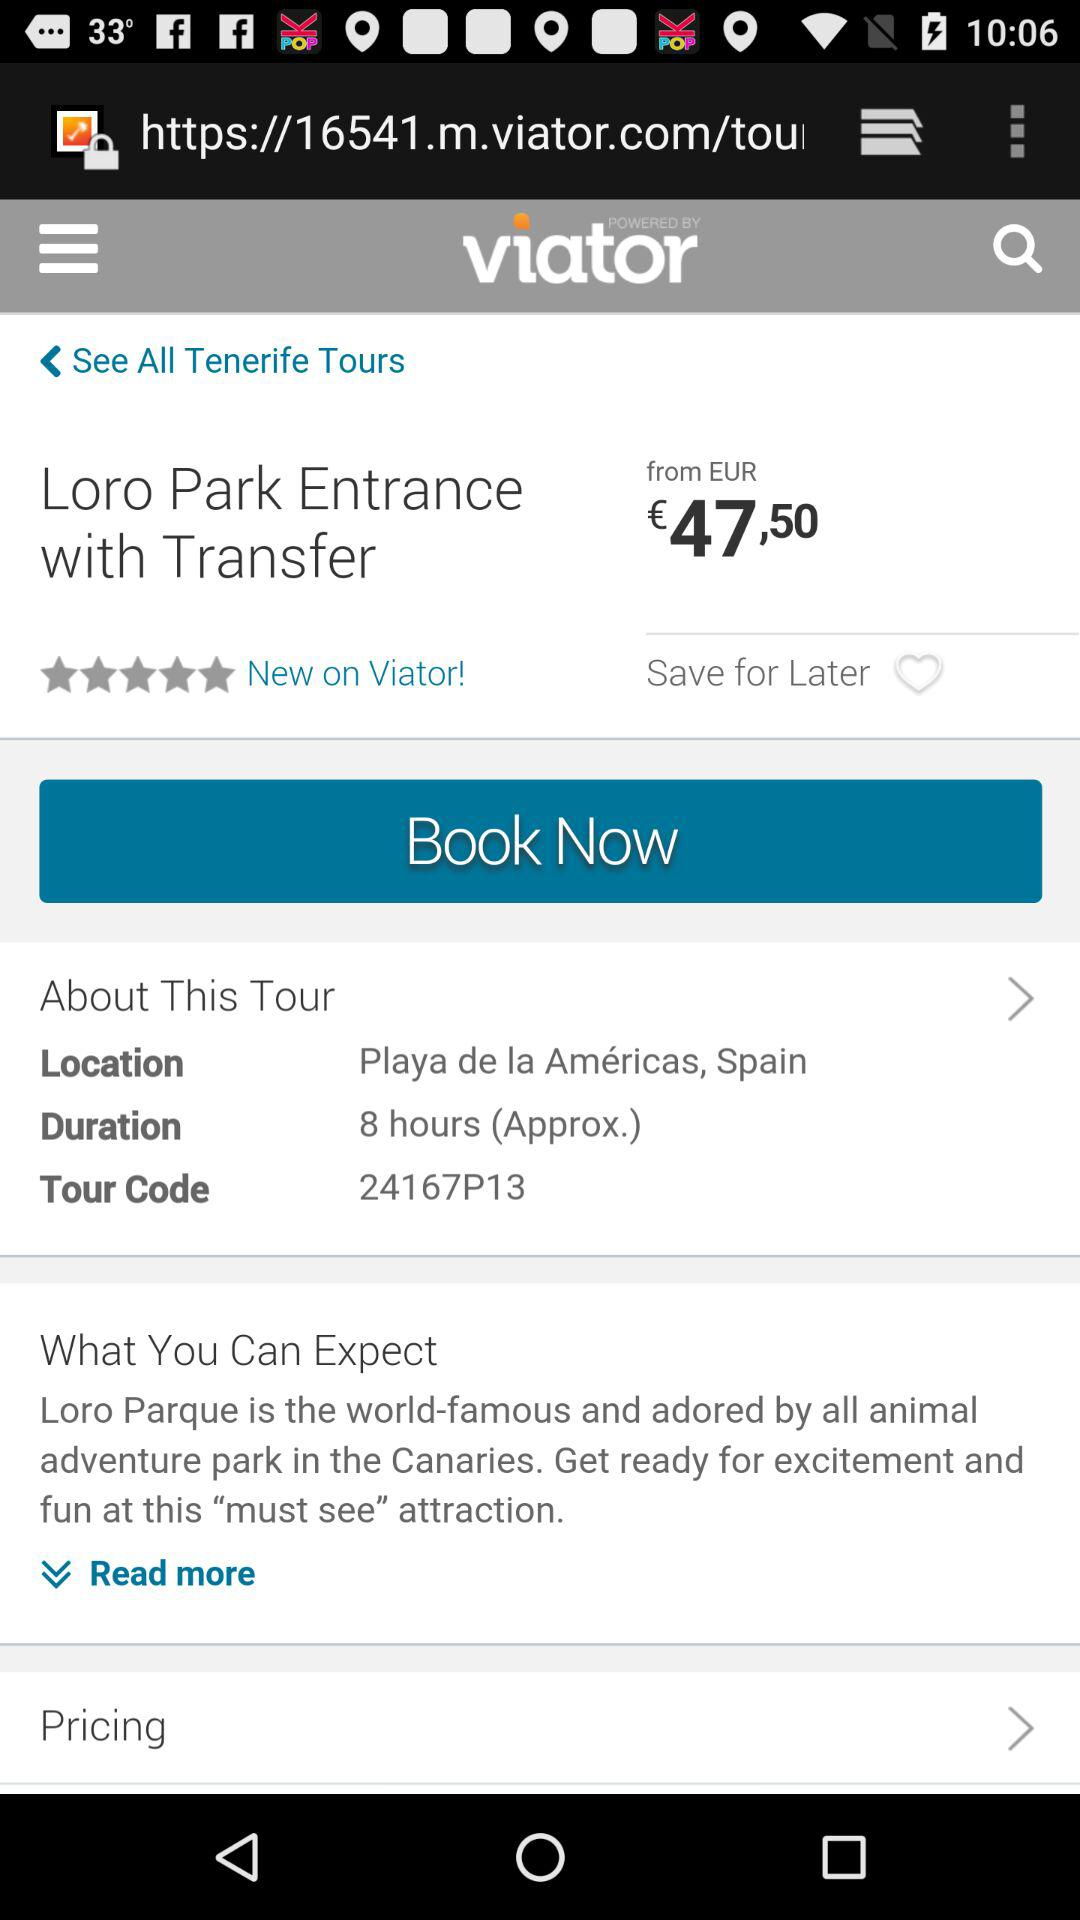What is the price of the "Loro Park" entry ticket? The price starts at 47.50 EUR. 